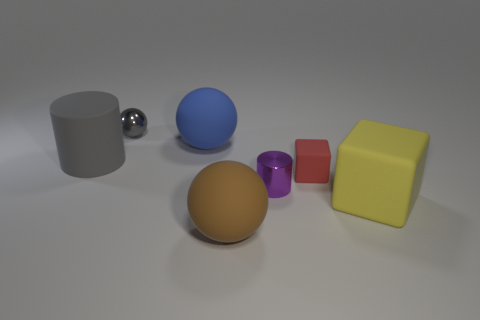The small shiny object that is on the right side of the large rubber ball in front of the large gray object that is on the left side of the brown ball is what color?
Make the answer very short. Purple. What is the color of the large cube?
Ensure brevity in your answer.  Yellow. Does the large cylinder have the same color as the metallic cylinder?
Offer a terse response. No. Do the large thing that is right of the large brown rubber sphere and the sphere that is in front of the large gray object have the same material?
Offer a terse response. Yes. There is another tiny object that is the same shape as the yellow matte thing; what material is it?
Give a very brief answer. Rubber. Is the material of the gray cylinder the same as the blue thing?
Provide a succinct answer. Yes. What is the color of the large rubber sphere that is behind the small matte cube behind the purple metallic cylinder?
Ensure brevity in your answer.  Blue. What is the size of the blue ball that is made of the same material as the big brown ball?
Make the answer very short. Large. How many tiny brown objects are the same shape as the small gray metal thing?
Your response must be concise. 0. What number of objects are big spheres that are on the left side of the big brown rubber thing or blue balls that are on the right side of the tiny gray shiny object?
Your answer should be very brief. 1. 